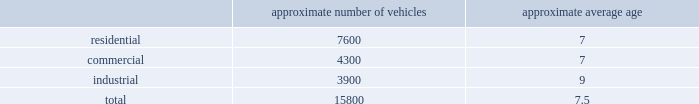Standardized maintenance based on an industry trade publication , we operate the eighth largest vocational fleet in the united states .
As of december 31 , 2014 , our average fleet age in years , by line of business , was as follows : approximate number of vehicles approximate average age .
Through standardization of core functions , we believe we can minimize variability in our maintenance processes resulting in higher vehicle quality while extending the service life of our fleet .
We believe operating a more reliable , safer and efficient fleet will lower our operating costs .
We have implemented standardized maintenance programs for approximately 60% ( 60 % ) of our fleet maintenance operations as of december 31 , 2014 .
Cash utilization strategy key components of our cash utilization strategy include increasing free cash flow and improving our return on invested capital .
Our definition of free cash flow , which is not a measure determined in accordance with united states generally accepted accounting principles ( u.s .
Gaap ) , is cash provided by operating activities less purchases of property and equipment , plus proceeds from sales of property and equipment as presented in our consolidated statements of cash flows .
For a discussion and reconciliation of free cash flow , you should read the 201cfree cash flow 201d section of our management 2019s discussion and analysis of financial condition and results of operations contained in item 7 of this form 10-k .
We believe free cash flow drives shareholder value and provides useful information regarding the recurring cash provided by our operations .
Free cash flow also demonstrates our ability to execute our cash utilization strategy , which includes investments in acquisitions and returning a majority of free cash flow to our shareholders through dividends and share repurchases .
We are committed to an efficient capital structure and maintaining our investment grade credit ratings .
We manage our free cash flow by ensuring that capital expenditures and operating asset levels are appropriate in light of our existing business and growth opportunities , and by closely managing our working capital , which consists primarily of accounts receivable , accounts payable , and accrued landfill and environmental costs .
Dividends in july 2003 , our board of directors initiated a quarterly cash dividend of $ 0.04 per share .
Our quarterly dividend has increased from time to time thereafter , the latest increase occurring in july 2014 to $ 0.28 per share , representing a 7.7% ( 7.7 % ) increase over that of the prior year .
Over the last 5 years , our dividend has increased at a compounded annual growth rate of 8.1% ( 8.1 % ) .
We expect to continue paying quarterly cash dividends and may consider additional dividend increases if we believe they will enhance shareholder value .
Share repurchases in october 2013 , our board of directors added $ 650 million to the existing share repurchase authorization originally approved in november 2010 .
From november 2010 to december 31 , 2014 , we used $ 1439.5 million to repurchase 46.6 million shares of our common stock at a weighted average cost per share of $ 30.88 .
As of december 31 , 2014 , there were $ 360.2 million remaining under our share repurchase authorization .
During 2015 , we expect to use our remaining authorization to repurchase more of our outstanding common stock. .
What is the ratio of the residential to the commercial number of vehicles? 
Rationale: there is 1.8 residential vehicles to the commercial vehicles
Computations: (7600 / 4300)
Answer: 1.76744. 